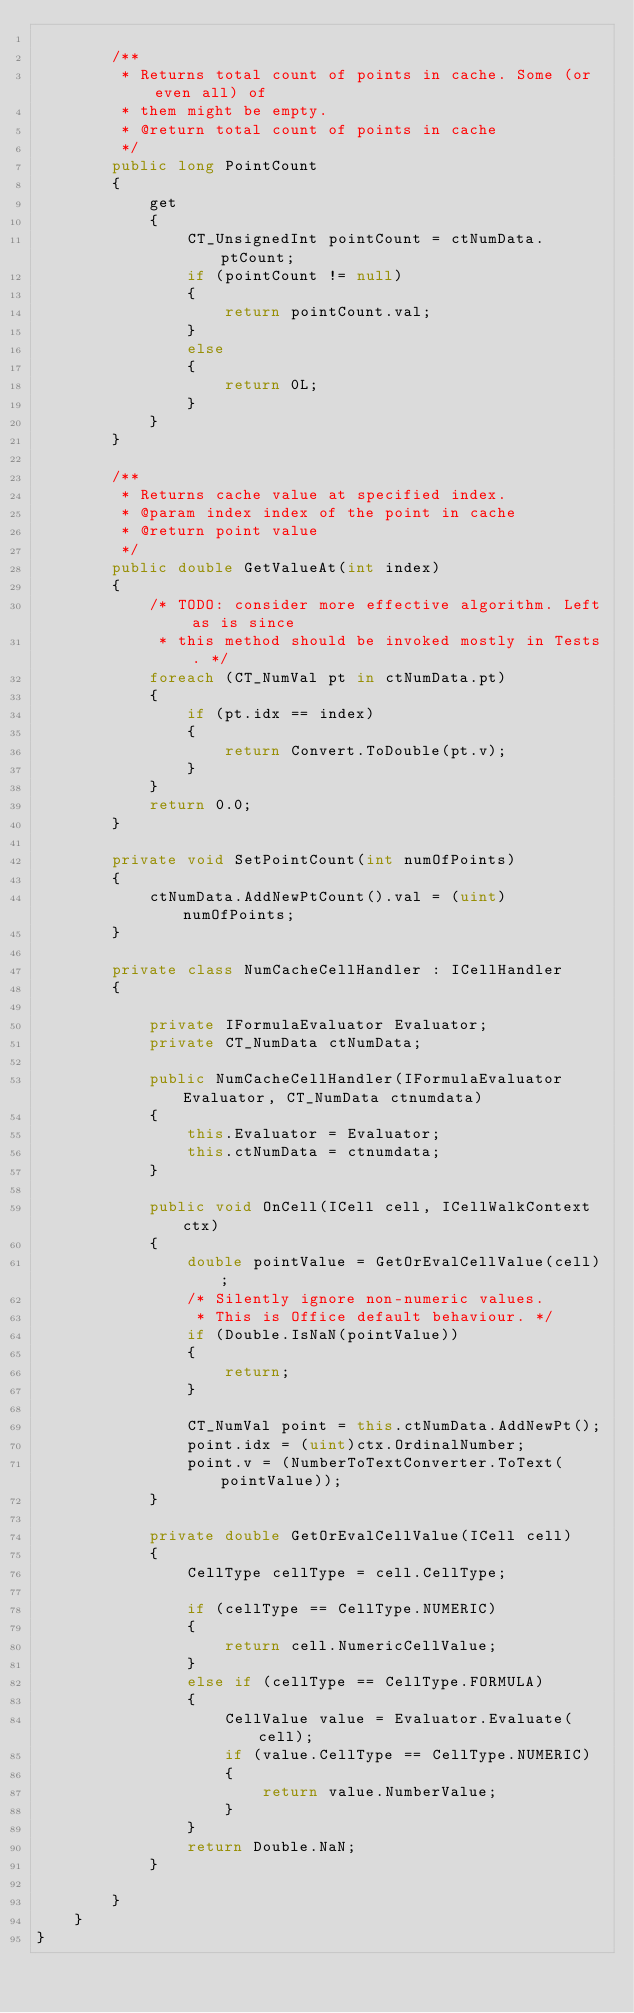Convert code to text. <code><loc_0><loc_0><loc_500><loc_500><_C#_>
        /**
         * Returns total count of points in cache. Some (or even all) of
         * them might be empty.
         * @return total count of points in cache
         */
        public long PointCount
        {
            get
            {
                CT_UnsignedInt pointCount = ctNumData.ptCount;
                if (pointCount != null)
                {
                    return pointCount.val;
                }
                else
                {
                    return 0L;
                }
            }
        }

        /**
         * Returns cache value at specified index.
         * @param index index of the point in cache
         * @return point value
         */
        public double GetValueAt(int index)
        {
            /* TODO: consider more effective algorithm. Left as is since
             * this method should be invoked mostly in Tests. */
            foreach (CT_NumVal pt in ctNumData.pt)
            {
                if (pt.idx == index)
                {
                    return Convert.ToDouble(pt.v);
                }
            }
            return 0.0;
        }

        private void SetPointCount(int numOfPoints)
        {
            ctNumData.AddNewPtCount().val = (uint)numOfPoints;
        }

        private class NumCacheCellHandler : ICellHandler
        {

            private IFormulaEvaluator Evaluator;
            private CT_NumData ctNumData;

            public NumCacheCellHandler(IFormulaEvaluator Evaluator, CT_NumData ctnumdata)
            {
                this.Evaluator = Evaluator;
                this.ctNumData = ctnumdata;
            }

            public void OnCell(ICell cell, ICellWalkContext ctx)
            {
                double pointValue = GetOrEvalCellValue(cell);
                /* Silently ignore non-numeric values.
                 * This is Office default behaviour. */
                if (Double.IsNaN(pointValue))
                {
                    return;
                }

                CT_NumVal point = this.ctNumData.AddNewPt();
                point.idx = (uint)ctx.OrdinalNumber;
                point.v = (NumberToTextConverter.ToText(pointValue));
            }

            private double GetOrEvalCellValue(ICell cell)
            {
                CellType cellType = cell.CellType;

                if (cellType == CellType.NUMERIC)
                {
                    return cell.NumericCellValue;
                }
                else if (cellType == CellType.FORMULA)
                {
                    CellValue value = Evaluator.Evaluate(cell);
                    if (value.CellType == CellType.NUMERIC)
                    {
                        return value.NumberValue;
                    }
                }
                return Double.NaN;
            }

        }
    }
}

</code> 